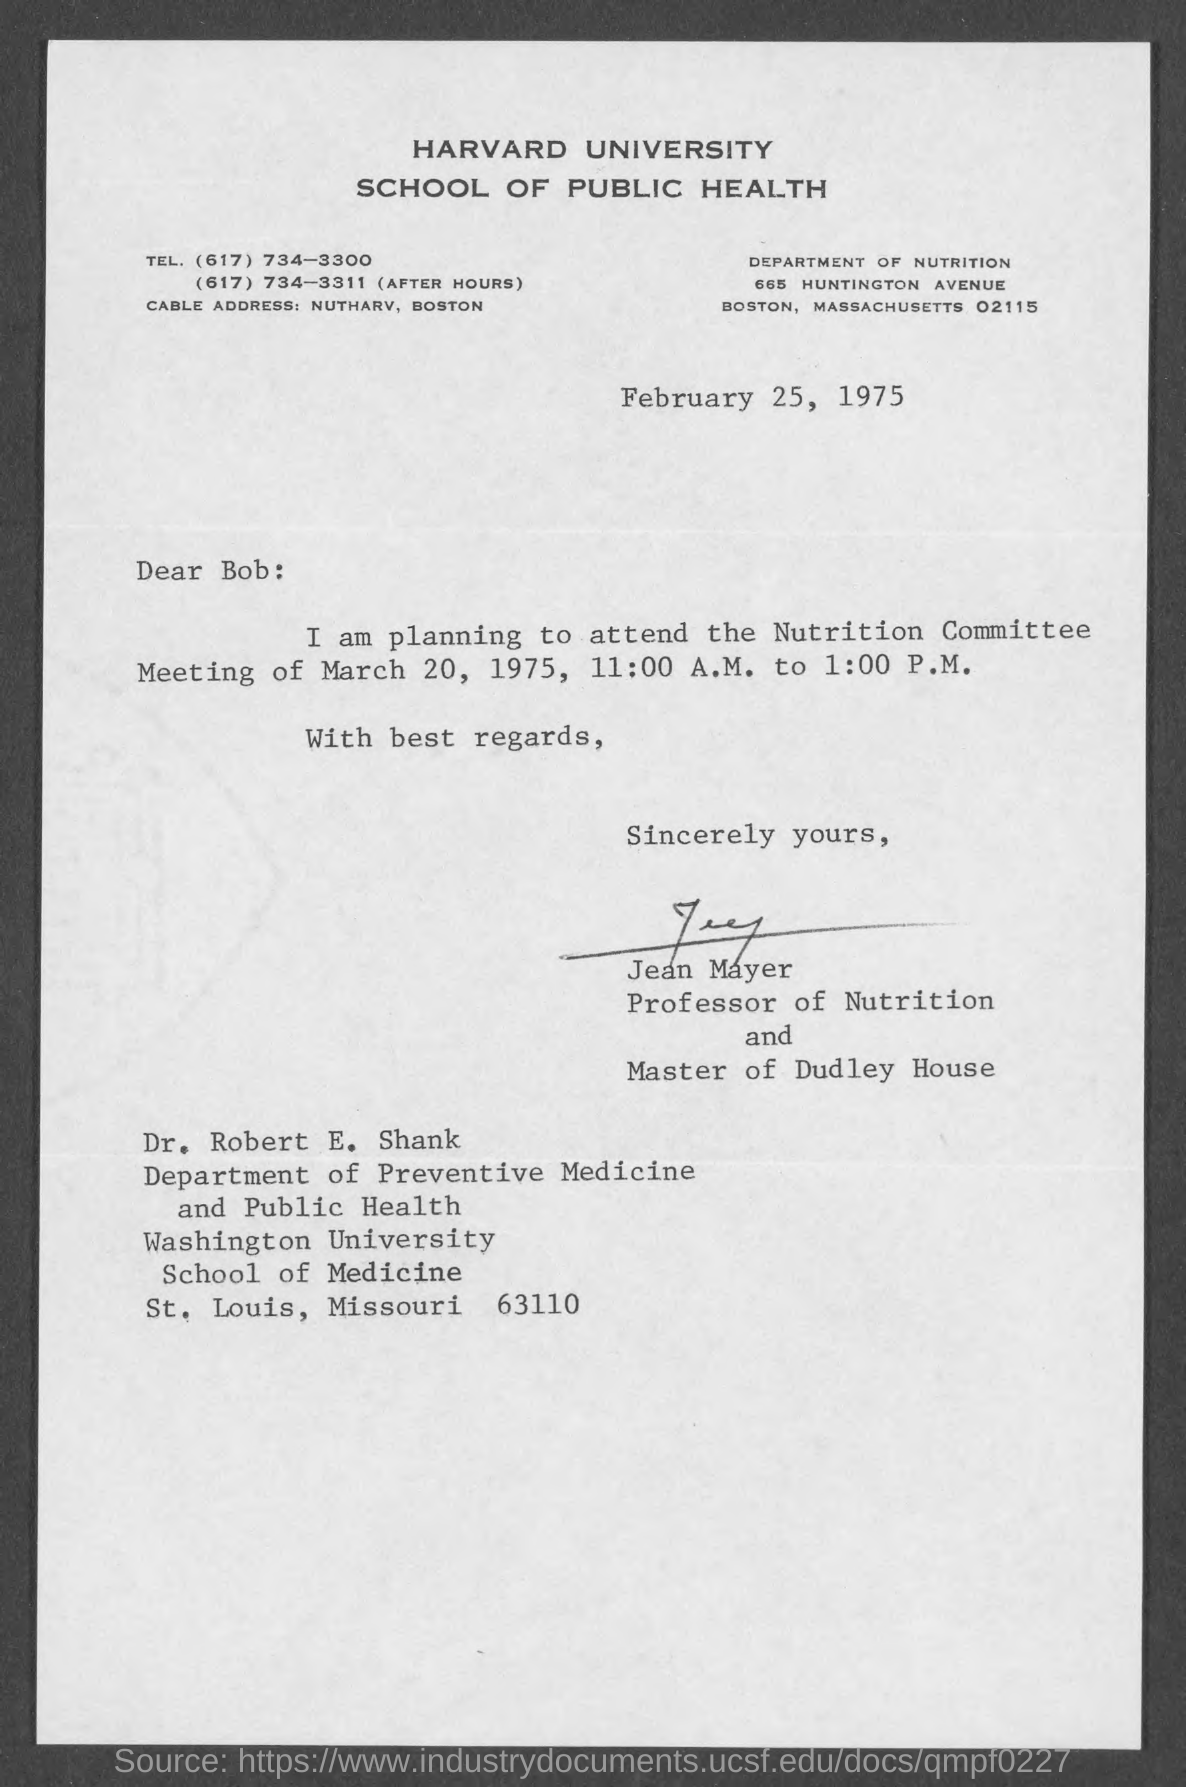Draw attention to some important aspects in this diagram. The text that appears on the letterhead is "Harvard University School of Public Health. Jean Mayer is the Professor of Nutrition. The date mentioned at the beginning of this document is February 25, 1975. 